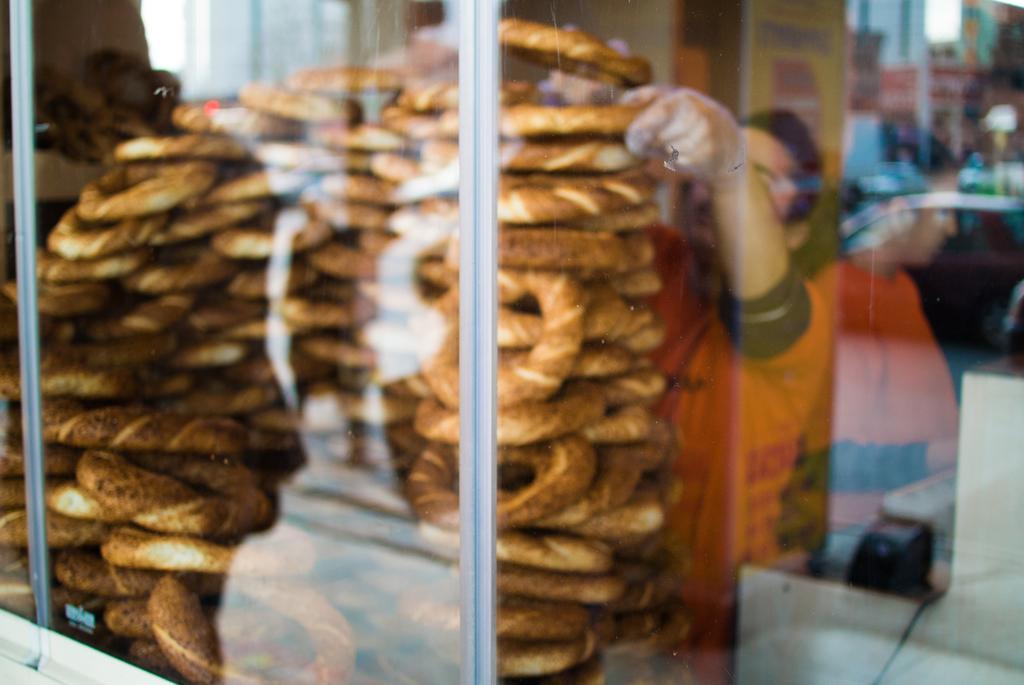In one or two sentences, can you explain what this image depicts? In this picture there are donuts in a glass container on the left side of the image and there is a man who is arranging donuts on the right side of the image. 